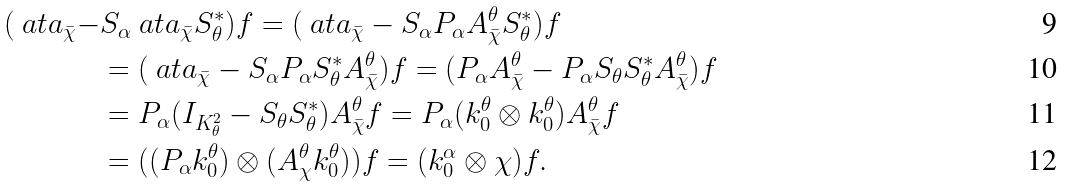<formula> <loc_0><loc_0><loc_500><loc_500>( \ a t a _ { \bar { \chi } } - & S _ { \alpha } \ a t a _ { \bar { \chi } } S ^ { * } _ { \theta } ) f = ( \ a t a _ { \bar { \chi } } - S _ { \alpha } P _ { \alpha } A ^ { \theta } _ { \bar { \chi } } S ^ { * } _ { \theta } ) f \\ & = ( \ a t a _ { \bar { \chi } } - S _ { \alpha } P _ { \alpha } S ^ { * } _ { \theta } A ^ { \theta } _ { \bar { \chi } } ) f = ( P _ { \alpha } A ^ { \theta } _ { \bar { \chi } } - P _ { \alpha } S _ { \theta } S ^ { * } _ { \theta } A ^ { \theta } _ { \bar { \chi } } ) f \\ & = P _ { \alpha } ( I _ { K ^ { 2 } _ { \theta } } - S _ { \theta } S _ { \theta } ^ { * } ) A ^ { \theta } _ { \bar { \chi } } f = P _ { \alpha } ( k _ { 0 } ^ { \theta } \otimes k _ { 0 } ^ { \theta } ) A ^ { \theta } _ { \bar { \chi } } f \\ & = ( ( P _ { \alpha } k _ { 0 } ^ { \theta } ) \otimes ( A ^ { \theta } _ { \chi } k _ { 0 } ^ { \theta } ) ) f = ( k _ { 0 } ^ { \alpha } \otimes \chi ) f .</formula> 